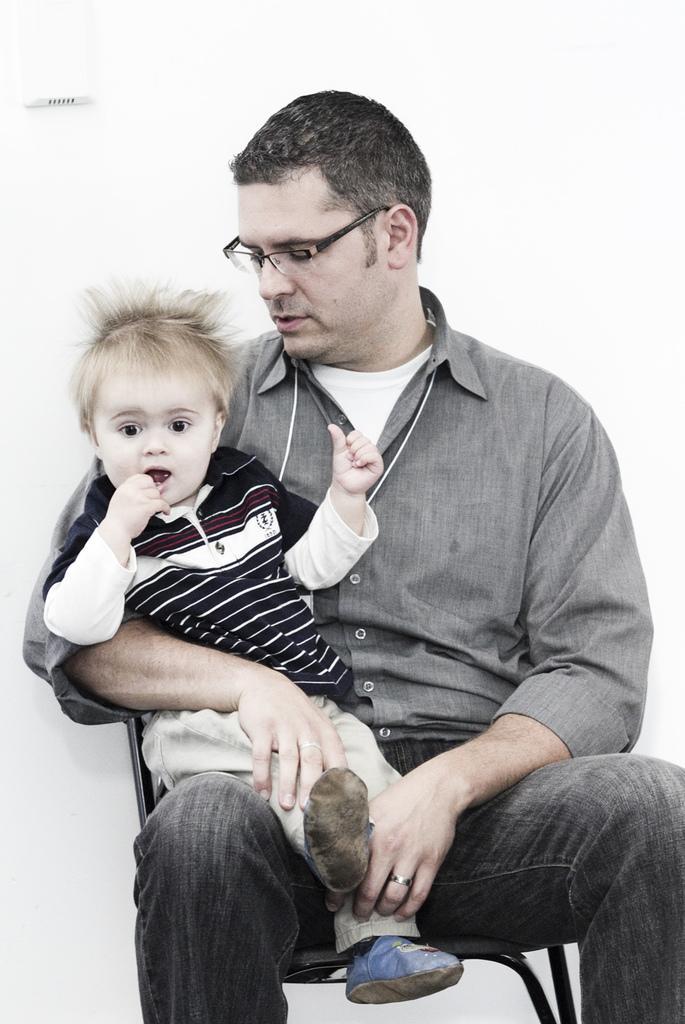Describe this image in one or two sentences. In this image I can see a man is sitting and I can see he is holding a baby. I can also see he is wearing shirt, jeans and specs. In the background I can see white colour. 